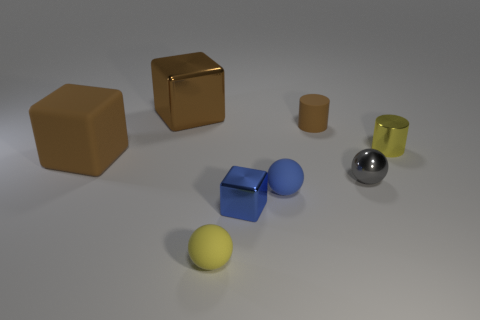How many small yellow things are to the left of the gray metal sphere and on the right side of the yellow matte ball?
Keep it short and to the point. 0. Do the yellow cylinder and the small brown object have the same material?
Offer a terse response. No. What is the shape of the blue matte object that is the same size as the gray thing?
Ensure brevity in your answer.  Sphere. Are there more large cyan matte things than small shiny spheres?
Ensure brevity in your answer.  No. The small object that is behind the small gray ball and to the left of the tiny yellow metal cylinder is made of what material?
Offer a terse response. Rubber. What number of tiny shiny things are the same color as the metal sphere?
Make the answer very short. 0. How big is the metal cube right of the metal block that is behind the brown cube that is on the left side of the brown metallic object?
Offer a very short reply. Small. What number of rubber things are either tiny blue cubes or yellow cylinders?
Your response must be concise. 0. Is the shape of the big shiny thing the same as the small yellow thing to the left of the brown matte cylinder?
Provide a succinct answer. No. Is the number of blue matte balls that are behind the tiny gray ball greater than the number of brown metal objects that are left of the tiny brown rubber thing?
Your answer should be compact. No. 